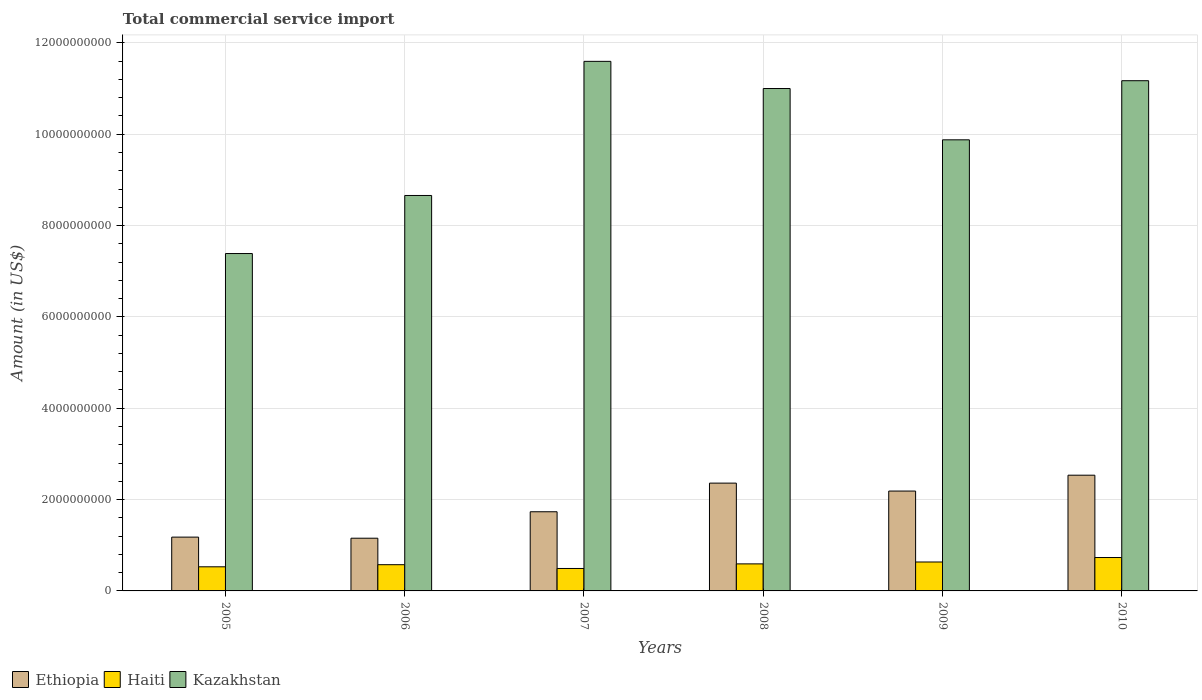Are the number of bars per tick equal to the number of legend labels?
Your answer should be very brief. Yes. Are the number of bars on each tick of the X-axis equal?
Offer a very short reply. Yes. How many bars are there on the 6th tick from the right?
Make the answer very short. 3. In how many cases, is the number of bars for a given year not equal to the number of legend labels?
Provide a succinct answer. 0. What is the total commercial service import in Kazakhstan in 2005?
Provide a succinct answer. 7.39e+09. Across all years, what is the maximum total commercial service import in Haiti?
Provide a succinct answer. 7.31e+08. Across all years, what is the minimum total commercial service import in Kazakhstan?
Give a very brief answer. 7.39e+09. In which year was the total commercial service import in Kazakhstan maximum?
Ensure brevity in your answer.  2007. What is the total total commercial service import in Kazakhstan in the graph?
Provide a succinct answer. 5.97e+1. What is the difference between the total commercial service import in Haiti in 2007 and that in 2010?
Your answer should be very brief. -2.40e+08. What is the difference between the total commercial service import in Haiti in 2007 and the total commercial service import in Ethiopia in 2005?
Your answer should be compact. -6.87e+08. What is the average total commercial service import in Kazakhstan per year?
Your answer should be compact. 9.95e+09. In the year 2006, what is the difference between the total commercial service import in Kazakhstan and total commercial service import in Haiti?
Ensure brevity in your answer.  8.08e+09. In how many years, is the total commercial service import in Ethiopia greater than 4000000000 US$?
Provide a succinct answer. 0. What is the ratio of the total commercial service import in Haiti in 2005 to that in 2008?
Offer a very short reply. 0.89. Is the total commercial service import in Kazakhstan in 2007 less than that in 2009?
Give a very brief answer. No. Is the difference between the total commercial service import in Kazakhstan in 2005 and 2007 greater than the difference between the total commercial service import in Haiti in 2005 and 2007?
Ensure brevity in your answer.  No. What is the difference between the highest and the second highest total commercial service import in Kazakhstan?
Offer a terse response. 4.24e+08. What is the difference between the highest and the lowest total commercial service import in Haiti?
Your response must be concise. 2.40e+08. Is the sum of the total commercial service import in Ethiopia in 2007 and 2010 greater than the maximum total commercial service import in Haiti across all years?
Your response must be concise. Yes. What does the 2nd bar from the left in 2009 represents?
Make the answer very short. Haiti. What does the 3rd bar from the right in 2007 represents?
Offer a terse response. Ethiopia. Is it the case that in every year, the sum of the total commercial service import in Kazakhstan and total commercial service import in Haiti is greater than the total commercial service import in Ethiopia?
Offer a terse response. Yes. How many bars are there?
Provide a short and direct response. 18. Are all the bars in the graph horizontal?
Ensure brevity in your answer.  No. Does the graph contain grids?
Keep it short and to the point. Yes. How many legend labels are there?
Give a very brief answer. 3. How are the legend labels stacked?
Keep it short and to the point. Horizontal. What is the title of the graph?
Provide a short and direct response. Total commercial service import. What is the label or title of the X-axis?
Give a very brief answer. Years. What is the label or title of the Y-axis?
Provide a short and direct response. Amount (in US$). What is the Amount (in US$) in Ethiopia in 2005?
Make the answer very short. 1.18e+09. What is the Amount (in US$) of Haiti in 2005?
Provide a succinct answer. 5.28e+08. What is the Amount (in US$) in Kazakhstan in 2005?
Make the answer very short. 7.39e+09. What is the Amount (in US$) in Ethiopia in 2006?
Offer a terse response. 1.15e+09. What is the Amount (in US$) in Haiti in 2006?
Offer a very short reply. 5.74e+08. What is the Amount (in US$) in Kazakhstan in 2006?
Your answer should be very brief. 8.66e+09. What is the Amount (in US$) of Ethiopia in 2007?
Your answer should be very brief. 1.73e+09. What is the Amount (in US$) in Haiti in 2007?
Your response must be concise. 4.91e+08. What is the Amount (in US$) of Kazakhstan in 2007?
Make the answer very short. 1.16e+1. What is the Amount (in US$) of Ethiopia in 2008?
Your answer should be very brief. 2.36e+09. What is the Amount (in US$) of Haiti in 2008?
Ensure brevity in your answer.  5.92e+08. What is the Amount (in US$) of Kazakhstan in 2008?
Make the answer very short. 1.10e+1. What is the Amount (in US$) of Ethiopia in 2009?
Offer a very short reply. 2.19e+09. What is the Amount (in US$) of Haiti in 2009?
Make the answer very short. 6.33e+08. What is the Amount (in US$) of Kazakhstan in 2009?
Offer a terse response. 9.88e+09. What is the Amount (in US$) of Ethiopia in 2010?
Give a very brief answer. 2.53e+09. What is the Amount (in US$) of Haiti in 2010?
Ensure brevity in your answer.  7.31e+08. What is the Amount (in US$) in Kazakhstan in 2010?
Your answer should be compact. 1.12e+1. Across all years, what is the maximum Amount (in US$) of Ethiopia?
Your answer should be compact. 2.53e+09. Across all years, what is the maximum Amount (in US$) of Haiti?
Your response must be concise. 7.31e+08. Across all years, what is the maximum Amount (in US$) of Kazakhstan?
Give a very brief answer. 1.16e+1. Across all years, what is the minimum Amount (in US$) in Ethiopia?
Ensure brevity in your answer.  1.15e+09. Across all years, what is the minimum Amount (in US$) in Haiti?
Your answer should be very brief. 4.91e+08. Across all years, what is the minimum Amount (in US$) of Kazakhstan?
Your answer should be compact. 7.39e+09. What is the total Amount (in US$) of Ethiopia in the graph?
Offer a very short reply. 1.11e+1. What is the total Amount (in US$) in Haiti in the graph?
Your response must be concise. 3.55e+09. What is the total Amount (in US$) in Kazakhstan in the graph?
Make the answer very short. 5.97e+1. What is the difference between the Amount (in US$) in Ethiopia in 2005 and that in 2006?
Your answer should be compact. 2.38e+07. What is the difference between the Amount (in US$) of Haiti in 2005 and that in 2006?
Ensure brevity in your answer.  -4.62e+07. What is the difference between the Amount (in US$) of Kazakhstan in 2005 and that in 2006?
Provide a succinct answer. -1.27e+09. What is the difference between the Amount (in US$) in Ethiopia in 2005 and that in 2007?
Make the answer very short. -5.55e+08. What is the difference between the Amount (in US$) of Haiti in 2005 and that in 2007?
Ensure brevity in your answer.  3.68e+07. What is the difference between the Amount (in US$) of Kazakhstan in 2005 and that in 2007?
Make the answer very short. -4.21e+09. What is the difference between the Amount (in US$) of Ethiopia in 2005 and that in 2008?
Your response must be concise. -1.18e+09. What is the difference between the Amount (in US$) in Haiti in 2005 and that in 2008?
Keep it short and to the point. -6.41e+07. What is the difference between the Amount (in US$) in Kazakhstan in 2005 and that in 2008?
Your answer should be very brief. -3.61e+09. What is the difference between the Amount (in US$) in Ethiopia in 2005 and that in 2009?
Keep it short and to the point. -1.01e+09. What is the difference between the Amount (in US$) of Haiti in 2005 and that in 2009?
Give a very brief answer. -1.05e+08. What is the difference between the Amount (in US$) in Kazakhstan in 2005 and that in 2009?
Offer a very short reply. -2.49e+09. What is the difference between the Amount (in US$) of Ethiopia in 2005 and that in 2010?
Offer a very short reply. -1.36e+09. What is the difference between the Amount (in US$) in Haiti in 2005 and that in 2010?
Keep it short and to the point. -2.03e+08. What is the difference between the Amount (in US$) in Kazakhstan in 2005 and that in 2010?
Keep it short and to the point. -3.78e+09. What is the difference between the Amount (in US$) in Ethiopia in 2006 and that in 2007?
Keep it short and to the point. -5.79e+08. What is the difference between the Amount (in US$) in Haiti in 2006 and that in 2007?
Your response must be concise. 8.30e+07. What is the difference between the Amount (in US$) in Kazakhstan in 2006 and that in 2007?
Keep it short and to the point. -2.94e+09. What is the difference between the Amount (in US$) in Ethiopia in 2006 and that in 2008?
Give a very brief answer. -1.21e+09. What is the difference between the Amount (in US$) in Haiti in 2006 and that in 2008?
Give a very brief answer. -1.79e+07. What is the difference between the Amount (in US$) in Kazakhstan in 2006 and that in 2008?
Give a very brief answer. -2.34e+09. What is the difference between the Amount (in US$) in Ethiopia in 2006 and that in 2009?
Give a very brief answer. -1.03e+09. What is the difference between the Amount (in US$) of Haiti in 2006 and that in 2009?
Make the answer very short. -5.90e+07. What is the difference between the Amount (in US$) of Kazakhstan in 2006 and that in 2009?
Offer a very short reply. -1.22e+09. What is the difference between the Amount (in US$) of Ethiopia in 2006 and that in 2010?
Your answer should be very brief. -1.38e+09. What is the difference between the Amount (in US$) in Haiti in 2006 and that in 2010?
Your answer should be very brief. -1.57e+08. What is the difference between the Amount (in US$) in Kazakhstan in 2006 and that in 2010?
Provide a short and direct response. -2.51e+09. What is the difference between the Amount (in US$) of Ethiopia in 2007 and that in 2008?
Your answer should be compact. -6.27e+08. What is the difference between the Amount (in US$) in Haiti in 2007 and that in 2008?
Keep it short and to the point. -1.01e+08. What is the difference between the Amount (in US$) of Kazakhstan in 2007 and that in 2008?
Offer a very short reply. 5.95e+08. What is the difference between the Amount (in US$) in Ethiopia in 2007 and that in 2009?
Provide a short and direct response. -4.53e+08. What is the difference between the Amount (in US$) in Haiti in 2007 and that in 2009?
Provide a succinct answer. -1.42e+08. What is the difference between the Amount (in US$) of Kazakhstan in 2007 and that in 2009?
Your answer should be compact. 1.72e+09. What is the difference between the Amount (in US$) of Ethiopia in 2007 and that in 2010?
Offer a terse response. -8.00e+08. What is the difference between the Amount (in US$) in Haiti in 2007 and that in 2010?
Provide a succinct answer. -2.40e+08. What is the difference between the Amount (in US$) in Kazakhstan in 2007 and that in 2010?
Your answer should be compact. 4.24e+08. What is the difference between the Amount (in US$) of Ethiopia in 2008 and that in 2009?
Your answer should be very brief. 1.74e+08. What is the difference between the Amount (in US$) of Haiti in 2008 and that in 2009?
Make the answer very short. -4.11e+07. What is the difference between the Amount (in US$) in Kazakhstan in 2008 and that in 2009?
Offer a terse response. 1.12e+09. What is the difference between the Amount (in US$) in Ethiopia in 2008 and that in 2010?
Your answer should be very brief. -1.73e+08. What is the difference between the Amount (in US$) in Haiti in 2008 and that in 2010?
Your answer should be compact. -1.39e+08. What is the difference between the Amount (in US$) in Kazakhstan in 2008 and that in 2010?
Ensure brevity in your answer.  -1.71e+08. What is the difference between the Amount (in US$) in Ethiopia in 2009 and that in 2010?
Your answer should be compact. -3.47e+08. What is the difference between the Amount (in US$) in Haiti in 2009 and that in 2010?
Your answer should be compact. -9.79e+07. What is the difference between the Amount (in US$) of Kazakhstan in 2009 and that in 2010?
Your answer should be very brief. -1.29e+09. What is the difference between the Amount (in US$) of Ethiopia in 2005 and the Amount (in US$) of Haiti in 2006?
Offer a very short reply. 6.04e+08. What is the difference between the Amount (in US$) in Ethiopia in 2005 and the Amount (in US$) in Kazakhstan in 2006?
Offer a very short reply. -7.48e+09. What is the difference between the Amount (in US$) in Haiti in 2005 and the Amount (in US$) in Kazakhstan in 2006?
Make the answer very short. -8.13e+09. What is the difference between the Amount (in US$) in Ethiopia in 2005 and the Amount (in US$) in Haiti in 2007?
Your response must be concise. 6.87e+08. What is the difference between the Amount (in US$) of Ethiopia in 2005 and the Amount (in US$) of Kazakhstan in 2007?
Your response must be concise. -1.04e+1. What is the difference between the Amount (in US$) of Haiti in 2005 and the Amount (in US$) of Kazakhstan in 2007?
Provide a succinct answer. -1.11e+1. What is the difference between the Amount (in US$) in Ethiopia in 2005 and the Amount (in US$) in Haiti in 2008?
Your answer should be very brief. 5.86e+08. What is the difference between the Amount (in US$) of Ethiopia in 2005 and the Amount (in US$) of Kazakhstan in 2008?
Your answer should be compact. -9.82e+09. What is the difference between the Amount (in US$) of Haiti in 2005 and the Amount (in US$) of Kazakhstan in 2008?
Your response must be concise. -1.05e+1. What is the difference between the Amount (in US$) in Ethiopia in 2005 and the Amount (in US$) in Haiti in 2009?
Provide a short and direct response. 5.45e+08. What is the difference between the Amount (in US$) in Ethiopia in 2005 and the Amount (in US$) in Kazakhstan in 2009?
Provide a succinct answer. -8.70e+09. What is the difference between the Amount (in US$) of Haiti in 2005 and the Amount (in US$) of Kazakhstan in 2009?
Give a very brief answer. -9.35e+09. What is the difference between the Amount (in US$) in Ethiopia in 2005 and the Amount (in US$) in Haiti in 2010?
Keep it short and to the point. 4.47e+08. What is the difference between the Amount (in US$) in Ethiopia in 2005 and the Amount (in US$) in Kazakhstan in 2010?
Provide a succinct answer. -9.99e+09. What is the difference between the Amount (in US$) in Haiti in 2005 and the Amount (in US$) in Kazakhstan in 2010?
Keep it short and to the point. -1.06e+1. What is the difference between the Amount (in US$) of Ethiopia in 2006 and the Amount (in US$) of Haiti in 2007?
Your answer should be compact. 6.63e+08. What is the difference between the Amount (in US$) of Ethiopia in 2006 and the Amount (in US$) of Kazakhstan in 2007?
Give a very brief answer. -1.04e+1. What is the difference between the Amount (in US$) in Haiti in 2006 and the Amount (in US$) in Kazakhstan in 2007?
Give a very brief answer. -1.10e+1. What is the difference between the Amount (in US$) in Ethiopia in 2006 and the Amount (in US$) in Haiti in 2008?
Offer a very short reply. 5.62e+08. What is the difference between the Amount (in US$) of Ethiopia in 2006 and the Amount (in US$) of Kazakhstan in 2008?
Your answer should be compact. -9.85e+09. What is the difference between the Amount (in US$) in Haiti in 2006 and the Amount (in US$) in Kazakhstan in 2008?
Make the answer very short. -1.04e+1. What is the difference between the Amount (in US$) in Ethiopia in 2006 and the Amount (in US$) in Haiti in 2009?
Keep it short and to the point. 5.21e+08. What is the difference between the Amount (in US$) of Ethiopia in 2006 and the Amount (in US$) of Kazakhstan in 2009?
Keep it short and to the point. -8.72e+09. What is the difference between the Amount (in US$) of Haiti in 2006 and the Amount (in US$) of Kazakhstan in 2009?
Ensure brevity in your answer.  -9.30e+09. What is the difference between the Amount (in US$) in Ethiopia in 2006 and the Amount (in US$) in Haiti in 2010?
Offer a terse response. 4.23e+08. What is the difference between the Amount (in US$) in Ethiopia in 2006 and the Amount (in US$) in Kazakhstan in 2010?
Your answer should be very brief. -1.00e+1. What is the difference between the Amount (in US$) of Haiti in 2006 and the Amount (in US$) of Kazakhstan in 2010?
Ensure brevity in your answer.  -1.06e+1. What is the difference between the Amount (in US$) in Ethiopia in 2007 and the Amount (in US$) in Haiti in 2008?
Give a very brief answer. 1.14e+09. What is the difference between the Amount (in US$) of Ethiopia in 2007 and the Amount (in US$) of Kazakhstan in 2008?
Make the answer very short. -9.27e+09. What is the difference between the Amount (in US$) of Haiti in 2007 and the Amount (in US$) of Kazakhstan in 2008?
Provide a short and direct response. -1.05e+1. What is the difference between the Amount (in US$) in Ethiopia in 2007 and the Amount (in US$) in Haiti in 2009?
Offer a terse response. 1.10e+09. What is the difference between the Amount (in US$) of Ethiopia in 2007 and the Amount (in US$) of Kazakhstan in 2009?
Make the answer very short. -8.14e+09. What is the difference between the Amount (in US$) of Haiti in 2007 and the Amount (in US$) of Kazakhstan in 2009?
Your response must be concise. -9.39e+09. What is the difference between the Amount (in US$) of Ethiopia in 2007 and the Amount (in US$) of Haiti in 2010?
Provide a succinct answer. 1.00e+09. What is the difference between the Amount (in US$) of Ethiopia in 2007 and the Amount (in US$) of Kazakhstan in 2010?
Ensure brevity in your answer.  -9.44e+09. What is the difference between the Amount (in US$) of Haiti in 2007 and the Amount (in US$) of Kazakhstan in 2010?
Give a very brief answer. -1.07e+1. What is the difference between the Amount (in US$) of Ethiopia in 2008 and the Amount (in US$) of Haiti in 2009?
Make the answer very short. 1.73e+09. What is the difference between the Amount (in US$) of Ethiopia in 2008 and the Amount (in US$) of Kazakhstan in 2009?
Offer a terse response. -7.52e+09. What is the difference between the Amount (in US$) in Haiti in 2008 and the Amount (in US$) in Kazakhstan in 2009?
Your answer should be compact. -9.29e+09. What is the difference between the Amount (in US$) in Ethiopia in 2008 and the Amount (in US$) in Haiti in 2010?
Provide a succinct answer. 1.63e+09. What is the difference between the Amount (in US$) of Ethiopia in 2008 and the Amount (in US$) of Kazakhstan in 2010?
Your response must be concise. -8.81e+09. What is the difference between the Amount (in US$) of Haiti in 2008 and the Amount (in US$) of Kazakhstan in 2010?
Ensure brevity in your answer.  -1.06e+1. What is the difference between the Amount (in US$) of Ethiopia in 2009 and the Amount (in US$) of Haiti in 2010?
Offer a terse response. 1.46e+09. What is the difference between the Amount (in US$) in Ethiopia in 2009 and the Amount (in US$) in Kazakhstan in 2010?
Make the answer very short. -8.98e+09. What is the difference between the Amount (in US$) of Haiti in 2009 and the Amount (in US$) of Kazakhstan in 2010?
Your response must be concise. -1.05e+1. What is the average Amount (in US$) of Ethiopia per year?
Your answer should be compact. 1.86e+09. What is the average Amount (in US$) in Haiti per year?
Provide a succinct answer. 5.92e+08. What is the average Amount (in US$) of Kazakhstan per year?
Offer a very short reply. 9.95e+09. In the year 2005, what is the difference between the Amount (in US$) in Ethiopia and Amount (in US$) in Haiti?
Provide a succinct answer. 6.50e+08. In the year 2005, what is the difference between the Amount (in US$) of Ethiopia and Amount (in US$) of Kazakhstan?
Ensure brevity in your answer.  -6.21e+09. In the year 2005, what is the difference between the Amount (in US$) of Haiti and Amount (in US$) of Kazakhstan?
Offer a terse response. -6.86e+09. In the year 2006, what is the difference between the Amount (in US$) of Ethiopia and Amount (in US$) of Haiti?
Your answer should be very brief. 5.80e+08. In the year 2006, what is the difference between the Amount (in US$) of Ethiopia and Amount (in US$) of Kazakhstan?
Give a very brief answer. -7.50e+09. In the year 2006, what is the difference between the Amount (in US$) of Haiti and Amount (in US$) of Kazakhstan?
Make the answer very short. -8.08e+09. In the year 2007, what is the difference between the Amount (in US$) of Ethiopia and Amount (in US$) of Haiti?
Keep it short and to the point. 1.24e+09. In the year 2007, what is the difference between the Amount (in US$) of Ethiopia and Amount (in US$) of Kazakhstan?
Ensure brevity in your answer.  -9.86e+09. In the year 2007, what is the difference between the Amount (in US$) of Haiti and Amount (in US$) of Kazakhstan?
Your response must be concise. -1.11e+1. In the year 2008, what is the difference between the Amount (in US$) of Ethiopia and Amount (in US$) of Haiti?
Ensure brevity in your answer.  1.77e+09. In the year 2008, what is the difference between the Amount (in US$) of Ethiopia and Amount (in US$) of Kazakhstan?
Provide a succinct answer. -8.64e+09. In the year 2008, what is the difference between the Amount (in US$) of Haiti and Amount (in US$) of Kazakhstan?
Make the answer very short. -1.04e+1. In the year 2009, what is the difference between the Amount (in US$) in Ethiopia and Amount (in US$) in Haiti?
Offer a very short reply. 1.55e+09. In the year 2009, what is the difference between the Amount (in US$) of Ethiopia and Amount (in US$) of Kazakhstan?
Give a very brief answer. -7.69e+09. In the year 2009, what is the difference between the Amount (in US$) in Haiti and Amount (in US$) in Kazakhstan?
Keep it short and to the point. -9.24e+09. In the year 2010, what is the difference between the Amount (in US$) in Ethiopia and Amount (in US$) in Haiti?
Your answer should be very brief. 1.80e+09. In the year 2010, what is the difference between the Amount (in US$) of Ethiopia and Amount (in US$) of Kazakhstan?
Your response must be concise. -8.64e+09. In the year 2010, what is the difference between the Amount (in US$) of Haiti and Amount (in US$) of Kazakhstan?
Your answer should be compact. -1.04e+1. What is the ratio of the Amount (in US$) in Ethiopia in 2005 to that in 2006?
Give a very brief answer. 1.02. What is the ratio of the Amount (in US$) in Haiti in 2005 to that in 2006?
Provide a short and direct response. 0.92. What is the ratio of the Amount (in US$) of Kazakhstan in 2005 to that in 2006?
Your answer should be very brief. 0.85. What is the ratio of the Amount (in US$) in Ethiopia in 2005 to that in 2007?
Your answer should be compact. 0.68. What is the ratio of the Amount (in US$) of Haiti in 2005 to that in 2007?
Keep it short and to the point. 1.07. What is the ratio of the Amount (in US$) in Kazakhstan in 2005 to that in 2007?
Your answer should be very brief. 0.64. What is the ratio of the Amount (in US$) of Ethiopia in 2005 to that in 2008?
Keep it short and to the point. 0.5. What is the ratio of the Amount (in US$) of Haiti in 2005 to that in 2008?
Keep it short and to the point. 0.89. What is the ratio of the Amount (in US$) of Kazakhstan in 2005 to that in 2008?
Provide a short and direct response. 0.67. What is the ratio of the Amount (in US$) in Ethiopia in 2005 to that in 2009?
Offer a very short reply. 0.54. What is the ratio of the Amount (in US$) of Haiti in 2005 to that in 2009?
Provide a short and direct response. 0.83. What is the ratio of the Amount (in US$) in Kazakhstan in 2005 to that in 2009?
Offer a very short reply. 0.75. What is the ratio of the Amount (in US$) of Ethiopia in 2005 to that in 2010?
Your answer should be compact. 0.46. What is the ratio of the Amount (in US$) of Haiti in 2005 to that in 2010?
Your answer should be compact. 0.72. What is the ratio of the Amount (in US$) in Kazakhstan in 2005 to that in 2010?
Your answer should be compact. 0.66. What is the ratio of the Amount (in US$) in Ethiopia in 2006 to that in 2007?
Your response must be concise. 0.67. What is the ratio of the Amount (in US$) of Haiti in 2006 to that in 2007?
Your answer should be compact. 1.17. What is the ratio of the Amount (in US$) in Kazakhstan in 2006 to that in 2007?
Offer a terse response. 0.75. What is the ratio of the Amount (in US$) of Ethiopia in 2006 to that in 2008?
Offer a very short reply. 0.49. What is the ratio of the Amount (in US$) in Haiti in 2006 to that in 2008?
Offer a very short reply. 0.97. What is the ratio of the Amount (in US$) in Kazakhstan in 2006 to that in 2008?
Keep it short and to the point. 0.79. What is the ratio of the Amount (in US$) in Ethiopia in 2006 to that in 2009?
Your response must be concise. 0.53. What is the ratio of the Amount (in US$) of Haiti in 2006 to that in 2009?
Provide a short and direct response. 0.91. What is the ratio of the Amount (in US$) of Kazakhstan in 2006 to that in 2009?
Keep it short and to the point. 0.88. What is the ratio of the Amount (in US$) of Ethiopia in 2006 to that in 2010?
Give a very brief answer. 0.46. What is the ratio of the Amount (in US$) in Haiti in 2006 to that in 2010?
Offer a very short reply. 0.79. What is the ratio of the Amount (in US$) in Kazakhstan in 2006 to that in 2010?
Offer a very short reply. 0.78. What is the ratio of the Amount (in US$) of Ethiopia in 2007 to that in 2008?
Keep it short and to the point. 0.73. What is the ratio of the Amount (in US$) of Haiti in 2007 to that in 2008?
Provide a succinct answer. 0.83. What is the ratio of the Amount (in US$) in Kazakhstan in 2007 to that in 2008?
Make the answer very short. 1.05. What is the ratio of the Amount (in US$) of Ethiopia in 2007 to that in 2009?
Your answer should be very brief. 0.79. What is the ratio of the Amount (in US$) in Haiti in 2007 to that in 2009?
Ensure brevity in your answer.  0.78. What is the ratio of the Amount (in US$) of Kazakhstan in 2007 to that in 2009?
Your response must be concise. 1.17. What is the ratio of the Amount (in US$) in Ethiopia in 2007 to that in 2010?
Offer a terse response. 0.68. What is the ratio of the Amount (in US$) in Haiti in 2007 to that in 2010?
Offer a terse response. 0.67. What is the ratio of the Amount (in US$) of Kazakhstan in 2007 to that in 2010?
Your response must be concise. 1.04. What is the ratio of the Amount (in US$) in Ethiopia in 2008 to that in 2009?
Your answer should be very brief. 1.08. What is the ratio of the Amount (in US$) in Haiti in 2008 to that in 2009?
Your response must be concise. 0.94. What is the ratio of the Amount (in US$) in Kazakhstan in 2008 to that in 2009?
Give a very brief answer. 1.11. What is the ratio of the Amount (in US$) of Ethiopia in 2008 to that in 2010?
Provide a short and direct response. 0.93. What is the ratio of the Amount (in US$) in Haiti in 2008 to that in 2010?
Offer a very short reply. 0.81. What is the ratio of the Amount (in US$) in Kazakhstan in 2008 to that in 2010?
Offer a very short reply. 0.98. What is the ratio of the Amount (in US$) of Ethiopia in 2009 to that in 2010?
Give a very brief answer. 0.86. What is the ratio of the Amount (in US$) of Haiti in 2009 to that in 2010?
Give a very brief answer. 0.87. What is the ratio of the Amount (in US$) in Kazakhstan in 2009 to that in 2010?
Ensure brevity in your answer.  0.88. What is the difference between the highest and the second highest Amount (in US$) in Ethiopia?
Offer a terse response. 1.73e+08. What is the difference between the highest and the second highest Amount (in US$) in Haiti?
Your answer should be compact. 9.79e+07. What is the difference between the highest and the second highest Amount (in US$) of Kazakhstan?
Your answer should be compact. 4.24e+08. What is the difference between the highest and the lowest Amount (in US$) in Ethiopia?
Provide a short and direct response. 1.38e+09. What is the difference between the highest and the lowest Amount (in US$) in Haiti?
Provide a short and direct response. 2.40e+08. What is the difference between the highest and the lowest Amount (in US$) in Kazakhstan?
Provide a succinct answer. 4.21e+09. 